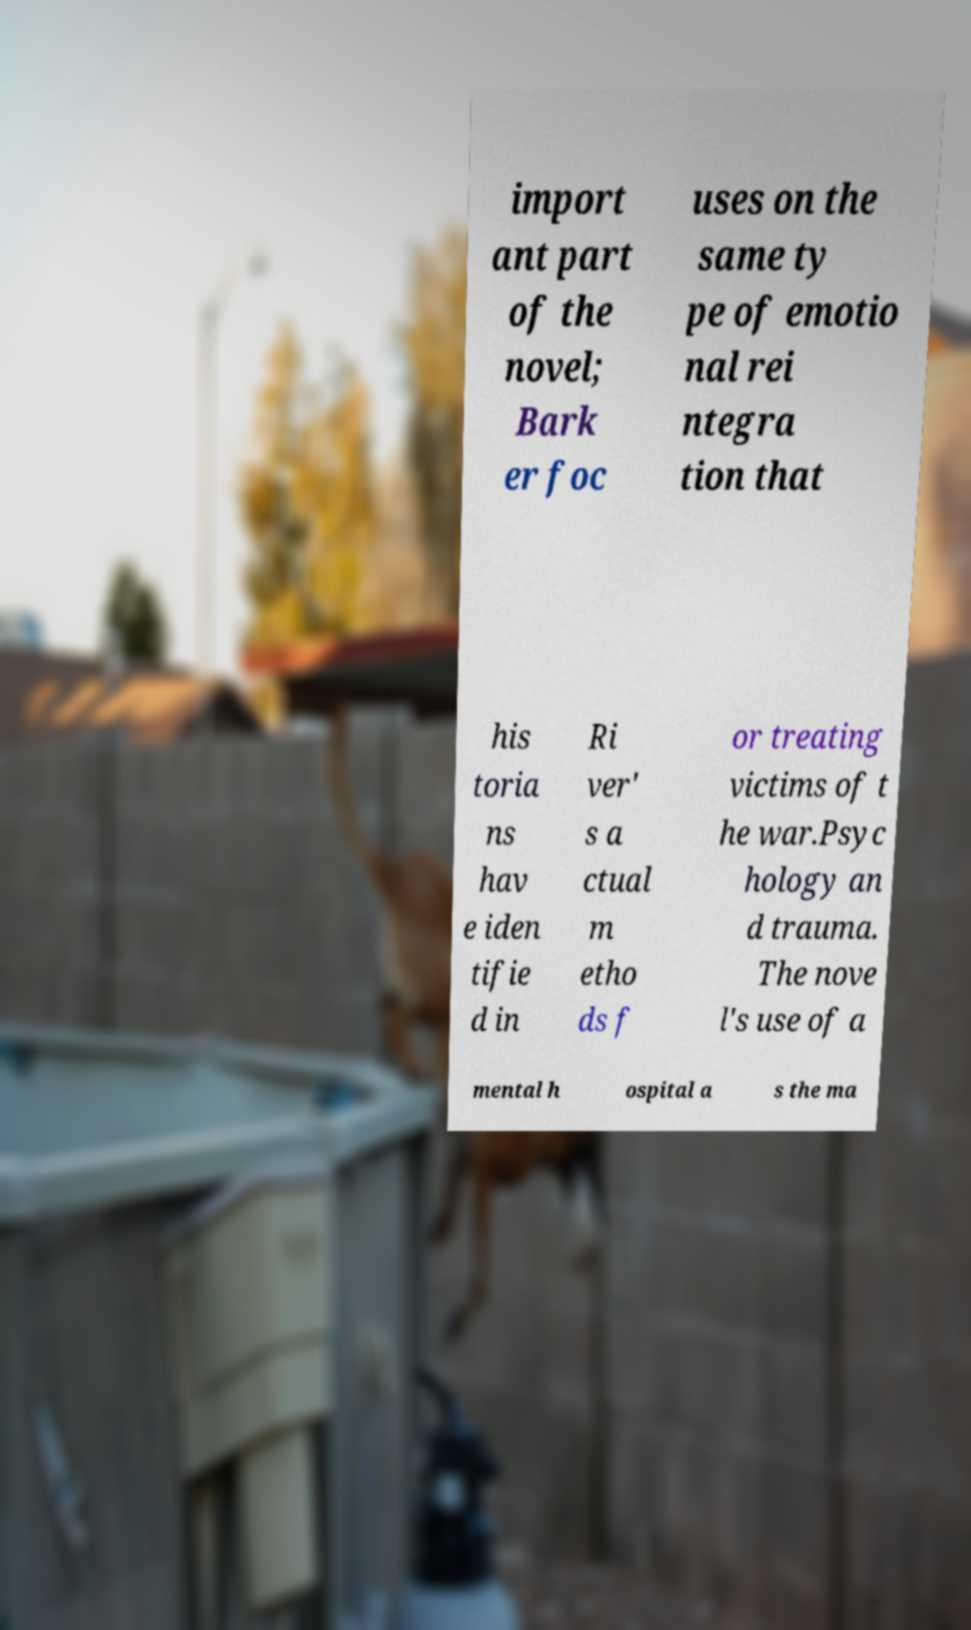Can you read and provide the text displayed in the image?This photo seems to have some interesting text. Can you extract and type it out for me? import ant part of the novel; Bark er foc uses on the same ty pe of emotio nal rei ntegra tion that his toria ns hav e iden tifie d in Ri ver' s a ctual m etho ds f or treating victims of t he war.Psyc hology an d trauma. The nove l's use of a mental h ospital a s the ma 